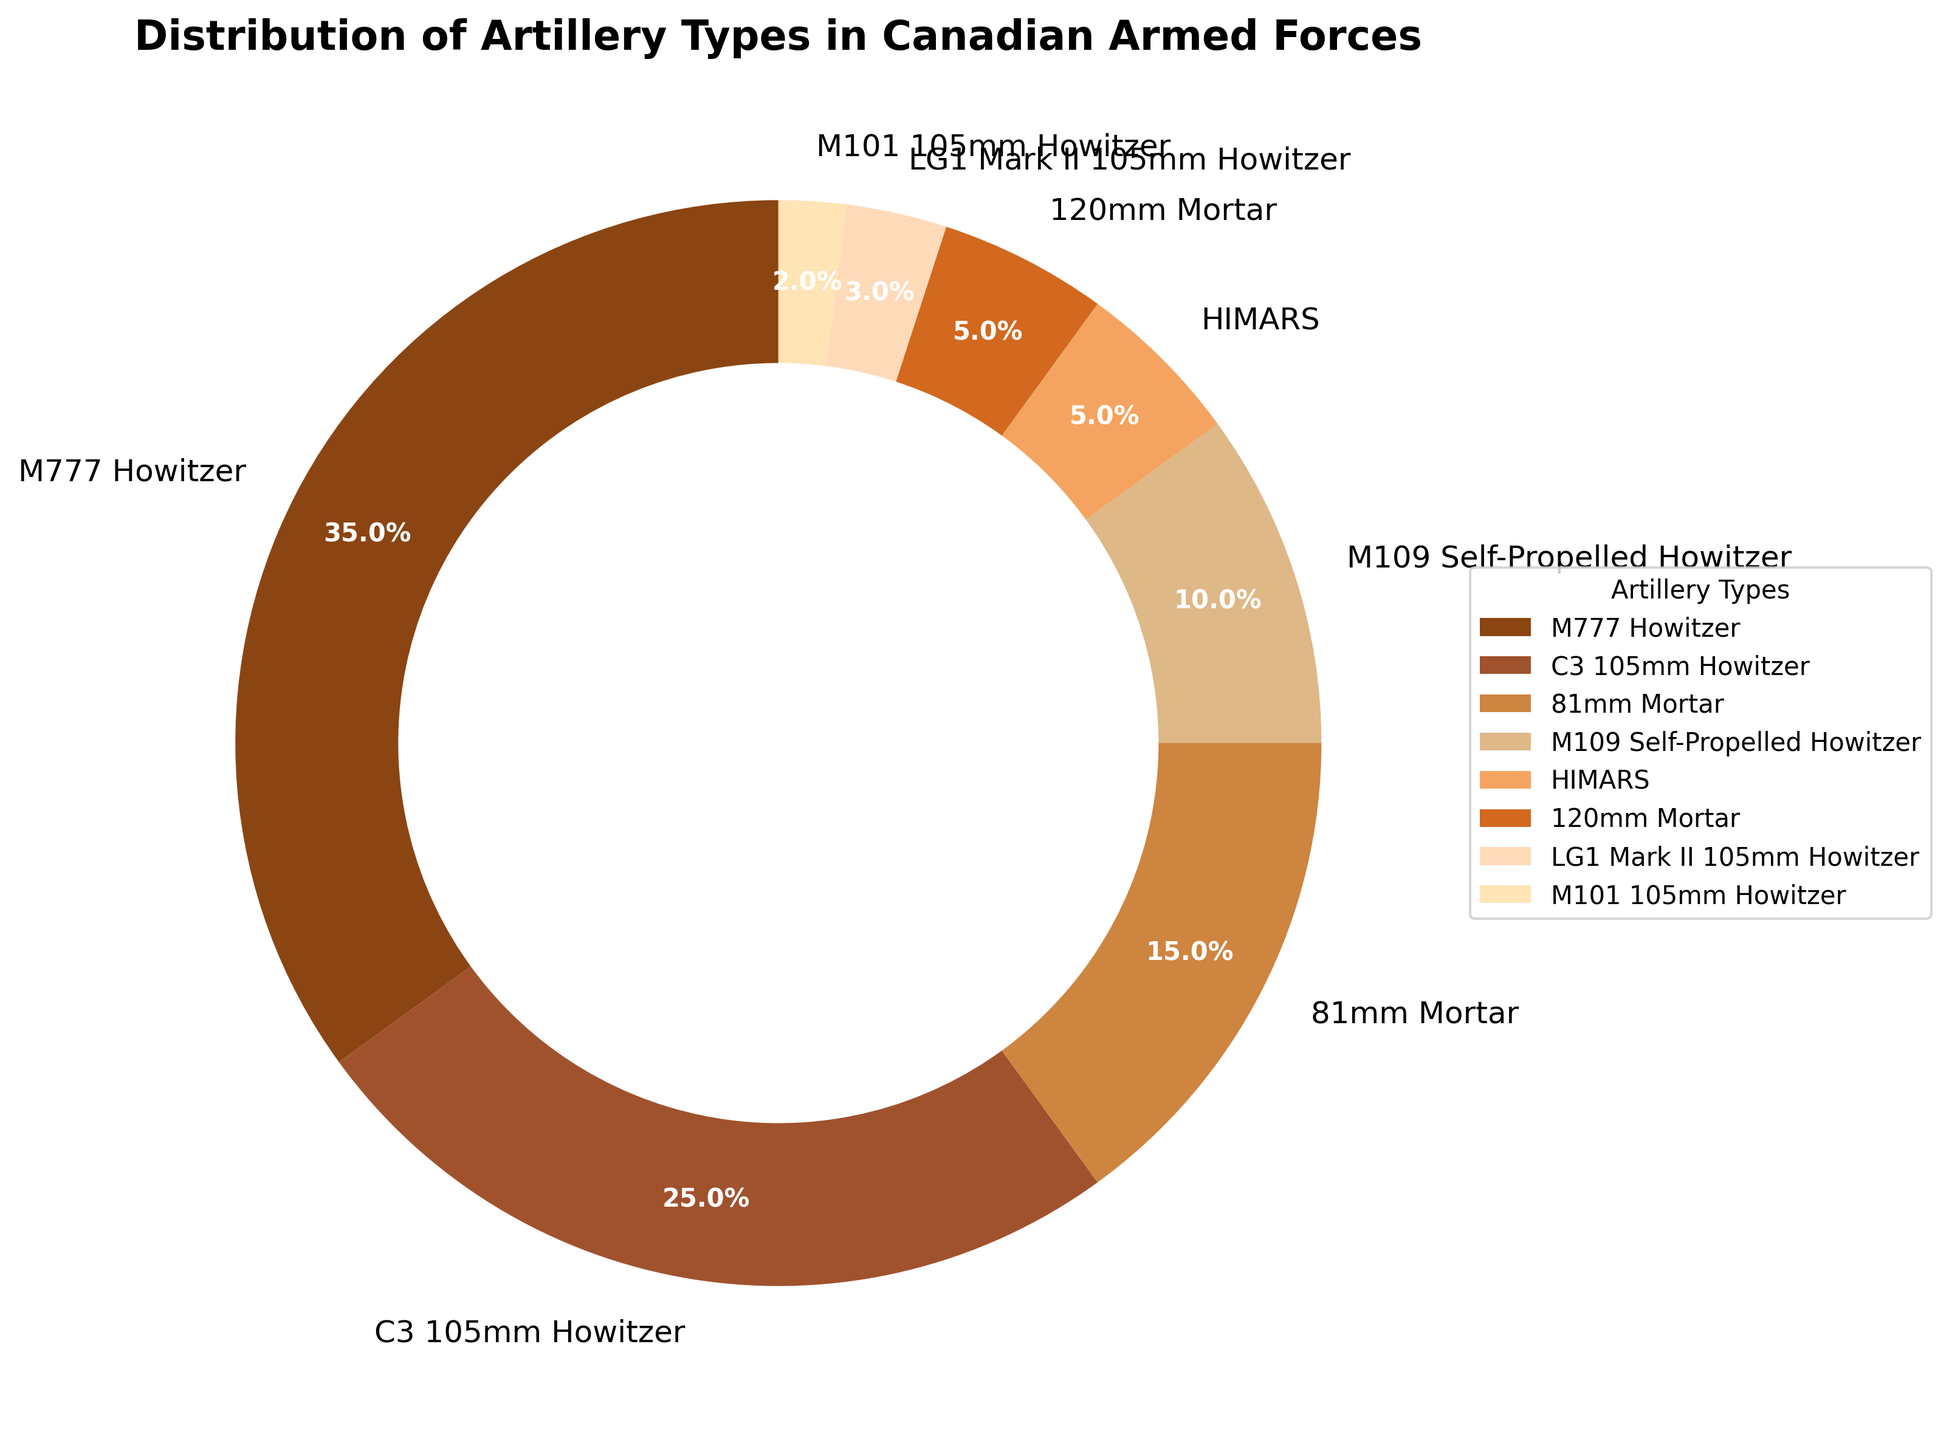Which artillery type constitutes the largest part of the pie chart? The M777 Howitzer is represented with the largest percentage in the pie chart, indicated by the largest wedge segment with a label showing 35%.
Answer: M777 Howitzer Which artillery type constitutes the smallest part of the pie chart? The M101 105mm Howitzer occupies the smallest part of the pie chart, with the smallest wedge segment showing 2%.
Answer: M101 105mm Howitzer What is the combined percentage of all artillery types that use howitzers? Adding the percentages of M777 Howitzer (35%), C3 105mm Howitzer (25%), M109 Self-Propelled Howitzer (10%), LG1 Mark II 105mm Howitzer (3%), and M101 105mm Howitzer (2%) gives a total of 35 + 25 + 10 + 3 + 2 = 75%.
Answer: 75% How many artillery types amount to more than 20% each? Only the M777 Howitzer at 35% and the C3 105mm Howitzer at 25% each have a percentage greater than 20%.
Answer: 2 Which has a greater percentage, 81mm Mortar or HIMARS? Comparing their percentages from the chart, 81mm Mortar is 15% and HIMARS is 5%. Therefore, 81mm Mortar has a greater percentage.
Answer: 81mm Mortar Between the 120mm Mortar and the LG1 Mark II 105mm Howitzer, which type has a larger representation and by how much? The 120mm Mortar has 5% while the LG1 Mark II 105mm Howitzer has 3%. Subtracting these gives 5 - 3 = 2%.
Answer: 120mm Mortar by 2% What is the mean percentage of M777 Howitzer, C3 105mm Howitzer, and M109 Self-Propelled Howitzer? Adding their percentages: M777 Howitzer (35%), C3 105mm Howitzer (25%), M109 Self-Propelled Howitzer (10%). The total is 35 + 25 + 10 = 70%. Dividing by 3 gives 70 / 3 = 23.33%.
Answer: 23.33% How does the percentage of M777 Howitzer compare to the combined percentage of HIMARS and 120mm Mortar? M777 Howitzer is 35%. The combined percentage of HIMARS (5%) and 120mm Mortar (5%) is 5 + 5 = 10%. Therefore, M777 Howitzer is larger by 35 - 10 = 25%.
Answer: M777 Howitzer is larger by 25% What percentage of artillery types occupy less than 10% each? Summing the percentages of M109 Self-Propelled Howitzer (10%), HIMARS (5%), 120mm Mortar (5%), LG1 Mark II 105mm Howitzer (3%), and M101 105mm Howitzer (2%) gives 10 + 5 + 5 + 3 + 2 = 25%.
Answer: 25% Which artillery types have a percentage displayed in light brown? The 81mm Mortar, at 15%, is displayed in light brown in the pie chart.
Answer: 81mm Mortar 